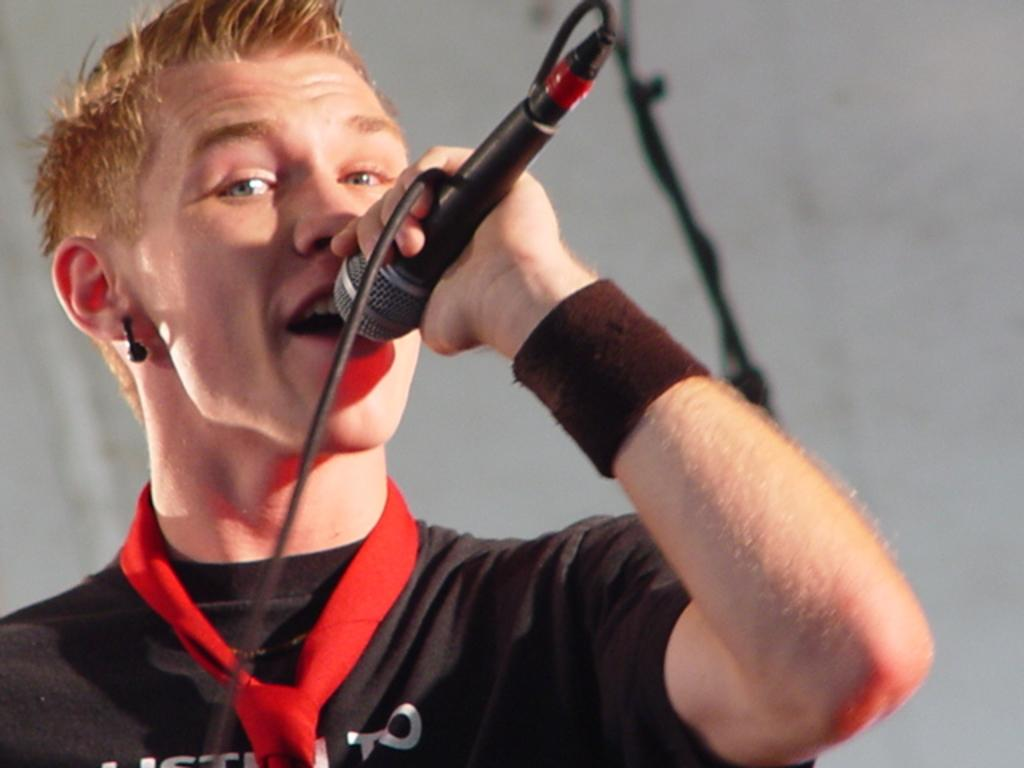What is the man in the image doing? The man is singing a song. What object is the man holding in the image? The man is holding a microphone. Is there anything connected to the microphone? Yes, there appears to be a wire attached to the microphone. Can you describe the man's attire in the image? The man is wearing a tie, a T-shirt, and an earring. Does the man's sister help him brush his tooth in the image? There is no mention of a tooth or a sister in the image, so we cannot answer this question. 